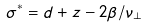<formula> <loc_0><loc_0><loc_500><loc_500>\sigma ^ { * } = d + z - 2 \beta / \nu _ { \perp } \,</formula> 